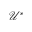Convert formula to latex. <formula><loc_0><loc_0><loc_500><loc_500>\mathcal { U } ^ { * }</formula> 